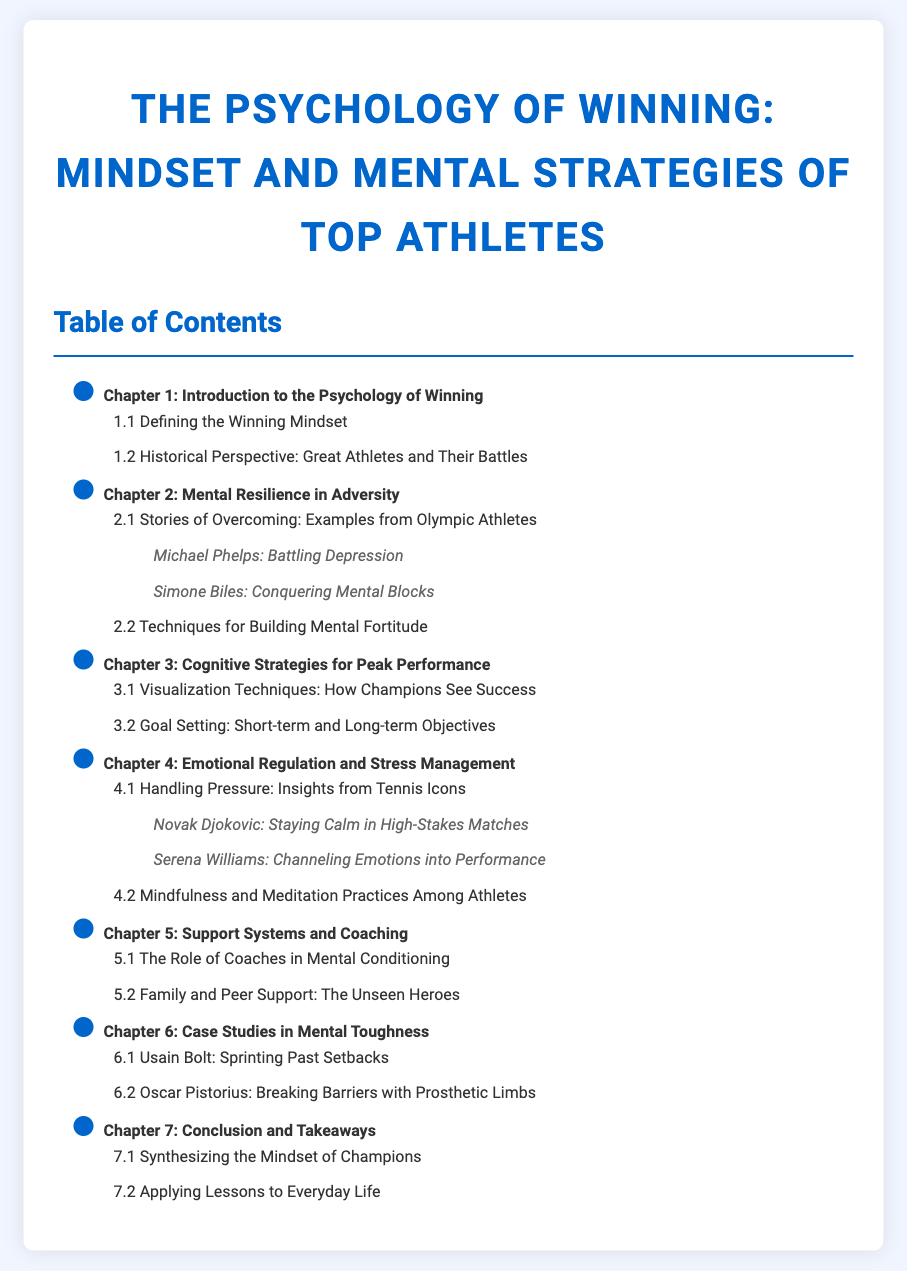what is the title of the document? The title is the primary heading of the document that summarizes its content.
Answer: The Psychology of Winning: Mindset and Mental Strategies of Top Athletes how many chapters are there in the document? The number of chapters can be counted from the Table of Contents list, which includes all the main headings.
Answer: 7 which chapter discusses emotional regulation? This chapter is specifically indicated in the Table of Contents, focusing on emotional aspects related to athletes.
Answer: Chapter 4: Emotional Regulation and Stress Management name one example of an athlete who overcame mental blocks. The Table of Contents lists specific examples under Chapter 2, making it clear which athletes are mentioned.
Answer: Simone Biles what is the focus of Chapter 6? The focus of the chapter is indicated in the title found in the Table of Contents, summarizing its contents succinctly.
Answer: Case Studies in Mental Toughness who is highlighted for staying calm under pressure? The specific athlete is mentioned as an example in Chapter 4 under the section about handling pressure.
Answer: Novak Djokovic what does Chapter 5 discuss about support systems? The chapter title provides a succinct overview of the subject matter related to supportive figures in an athlete's life.
Answer: Support Systems and Coaching what is one technique discussed in Chapter 2 for building resilience? Techniques for resilience are outlined in the section titles of Chapter 2 without providing details but hinting at practical approaches.
Answer: Techniques for Building Mental Fortitude 